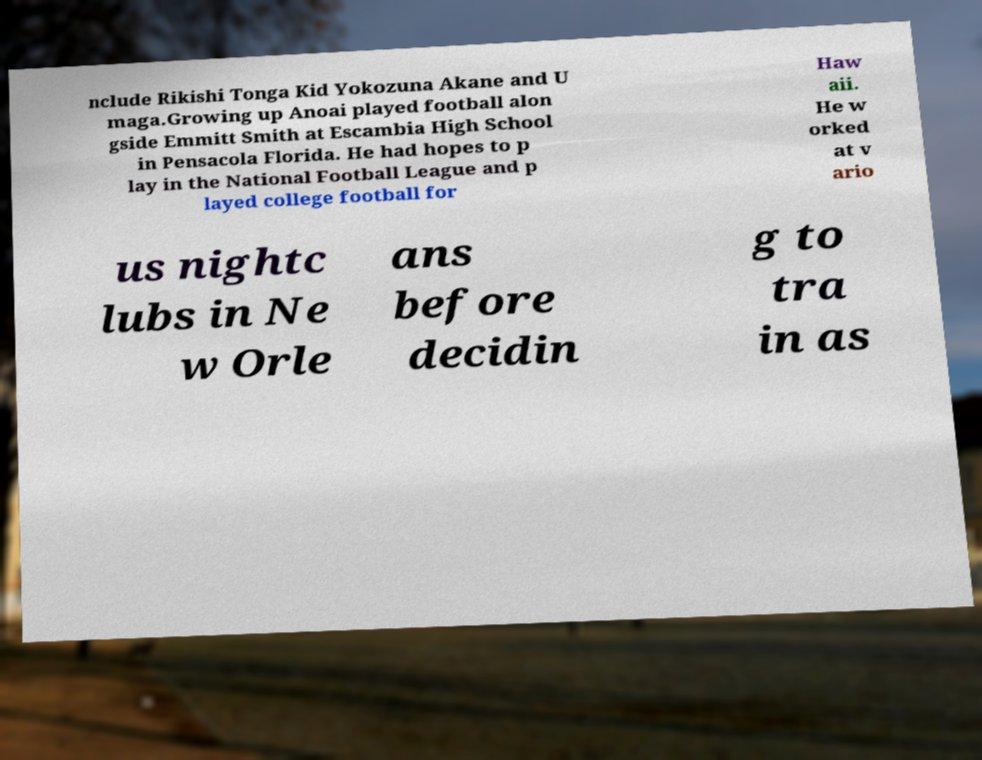Can you accurately transcribe the text from the provided image for me? nclude Rikishi Tonga Kid Yokozuna Akane and U maga.Growing up Anoai played football alon gside Emmitt Smith at Escambia High School in Pensacola Florida. He had hopes to p lay in the National Football League and p layed college football for Haw aii. He w orked at v ario us nightc lubs in Ne w Orle ans before decidin g to tra in as 